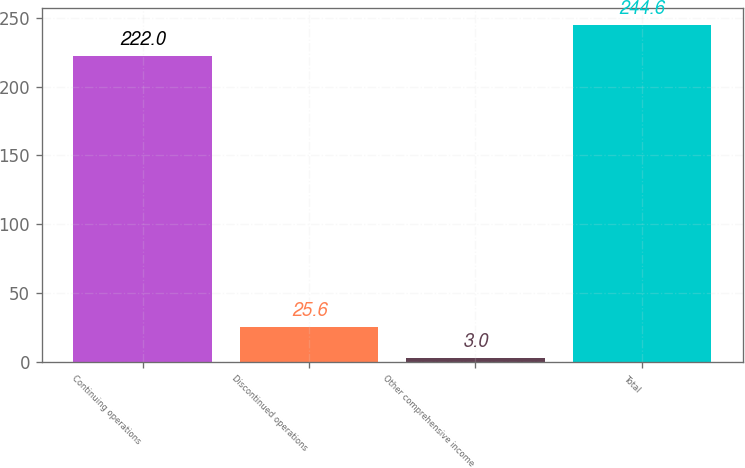Convert chart. <chart><loc_0><loc_0><loc_500><loc_500><bar_chart><fcel>Continuing operations<fcel>Discontinued operations<fcel>Other comprehensive income<fcel>Total<nl><fcel>222<fcel>25.6<fcel>3<fcel>244.6<nl></chart> 